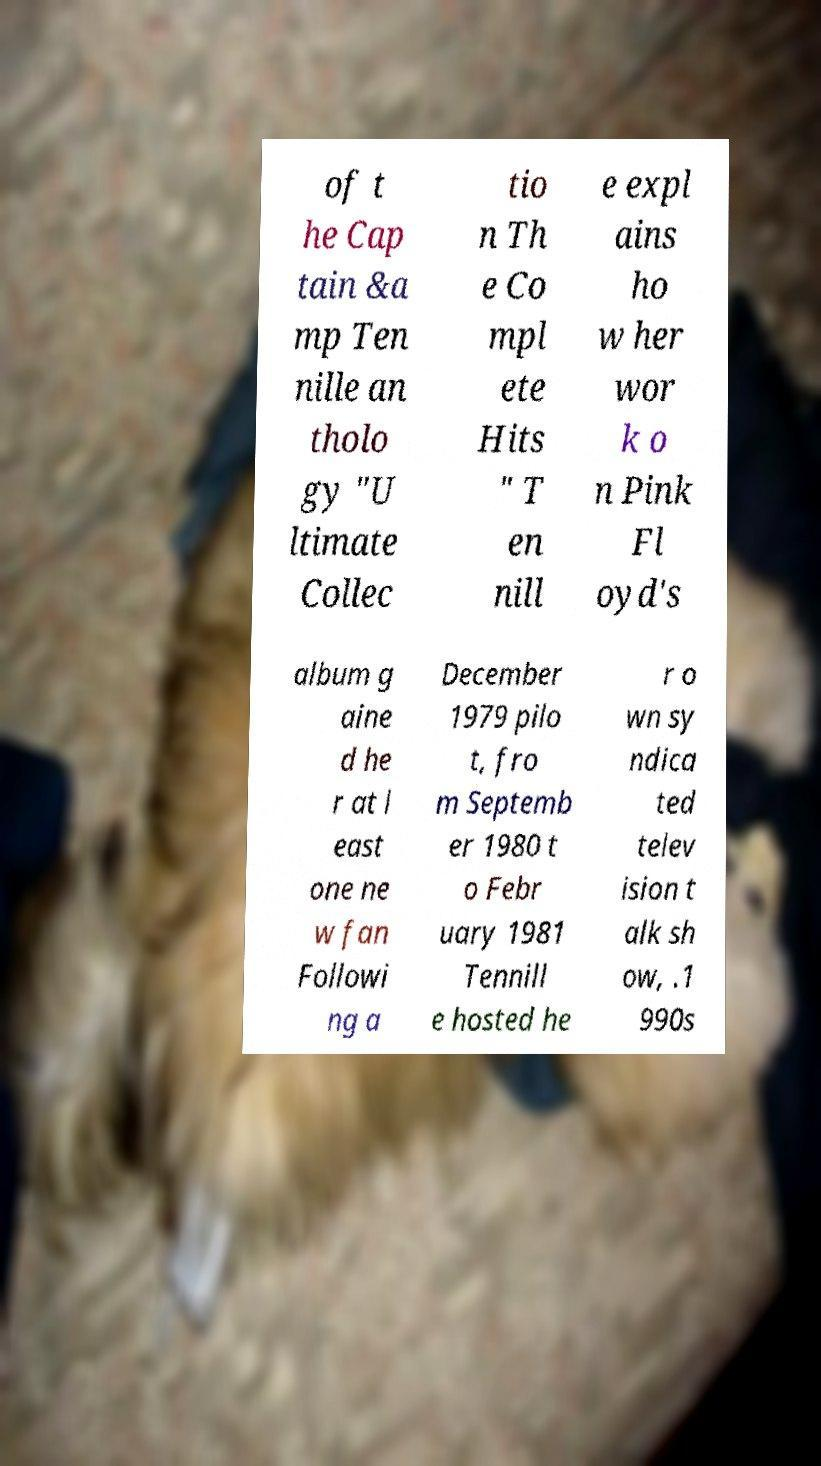What messages or text are displayed in this image? I need them in a readable, typed format. of t he Cap tain &a mp Ten nille an tholo gy "U ltimate Collec tio n Th e Co mpl ete Hits " T en nill e expl ains ho w her wor k o n Pink Fl oyd's album g aine d he r at l east one ne w fan Followi ng a December 1979 pilo t, fro m Septemb er 1980 t o Febr uary 1981 Tennill e hosted he r o wn sy ndica ted telev ision t alk sh ow, .1 990s 